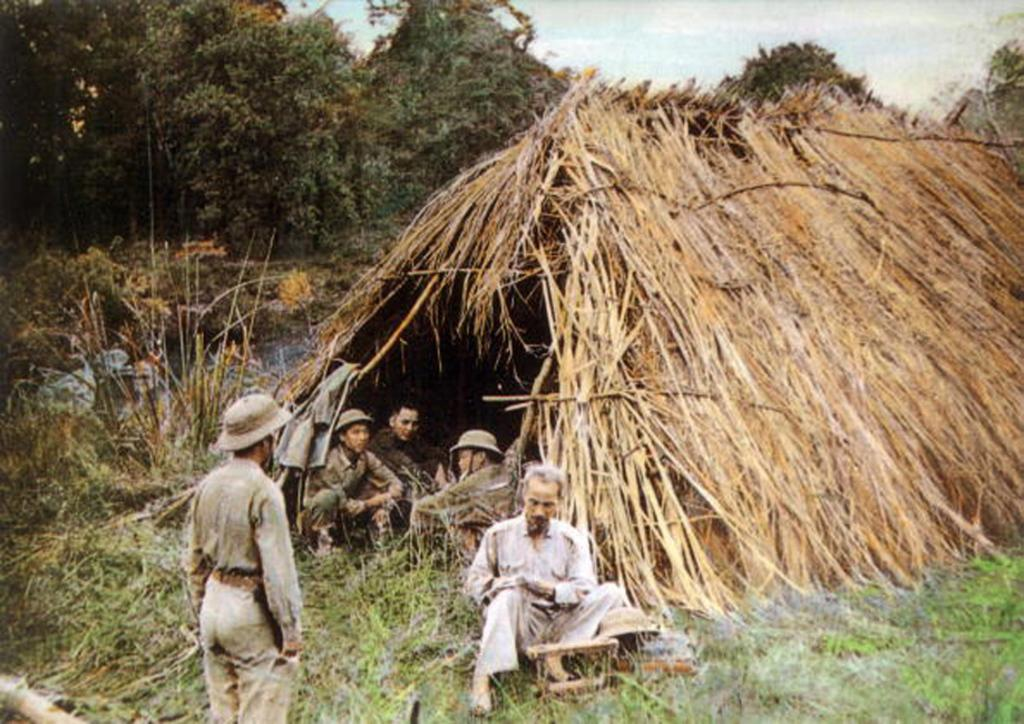What is the primary setting of the image? The primary setting of the image is outdoors, as there is grass, plants, trees, and the sky visible. What type of structure can be seen in the image? There is a hut in the image. What are the people in the image doing? The people in the image are on the ground, but their specific activities are not mentioned in the facts. What other objects are present in the image? There are other objects in the image, but their specific details are not mentioned in the facts. How many icicles are hanging from the hut in the image? There are no icicles present in the image, as it is set outdoors with grass, plants, trees, and the sky visible. 